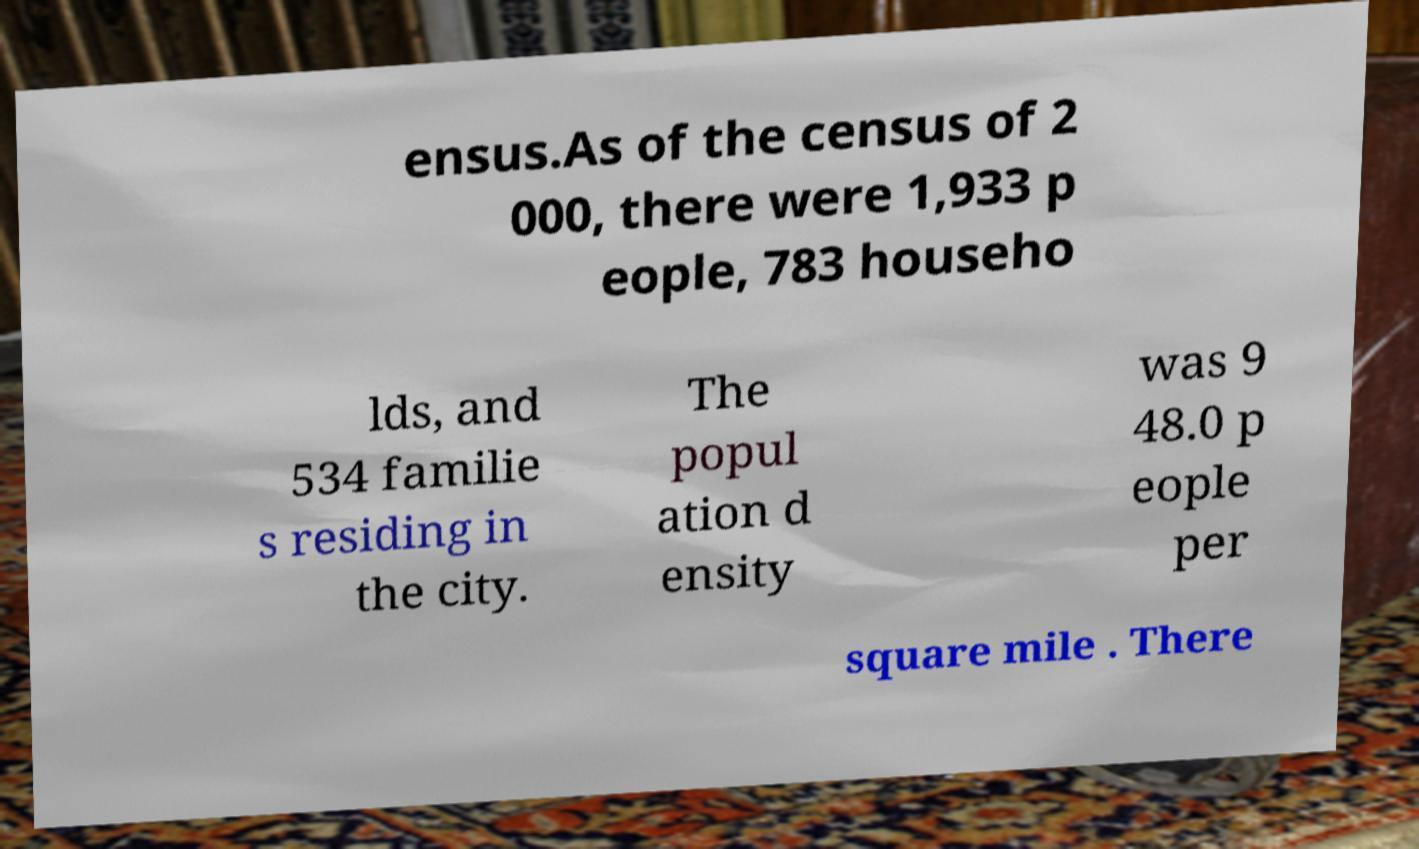Can you accurately transcribe the text from the provided image for me? ensus.As of the census of 2 000, there were 1,933 p eople, 783 househo lds, and 534 familie s residing in the city. The popul ation d ensity was 9 48.0 p eople per square mile . There 